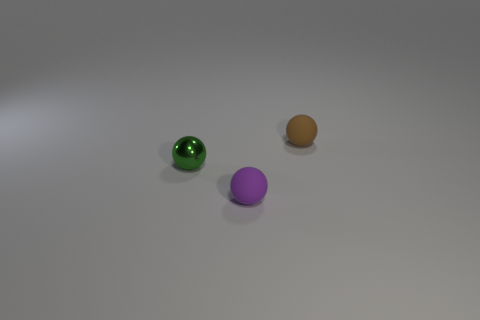How many other things are the same material as the small purple sphere?
Give a very brief answer. 1. The other small matte object that is the same shape as the brown object is what color?
Offer a terse response. Purple. Are there more tiny balls in front of the small brown thing than purple rubber objects?
Ensure brevity in your answer.  Yes. The rubber object that is on the right side of the tiny purple rubber sphere is what color?
Provide a short and direct response. Brown. Is the size of the brown rubber ball the same as the green metal ball?
Your answer should be very brief. Yes. Are there more brown balls than small rubber balls?
Keep it short and to the point. No. The rubber thing behind the matte sphere that is in front of the thing behind the small metal ball is what color?
Your answer should be compact. Brown. There is a rubber thing in front of the small green metallic sphere; is it the same shape as the tiny brown thing?
Keep it short and to the point. Yes. What color is the matte sphere that is the same size as the purple matte thing?
Offer a terse response. Brown. How many big blue matte blocks are there?
Keep it short and to the point. 0. 